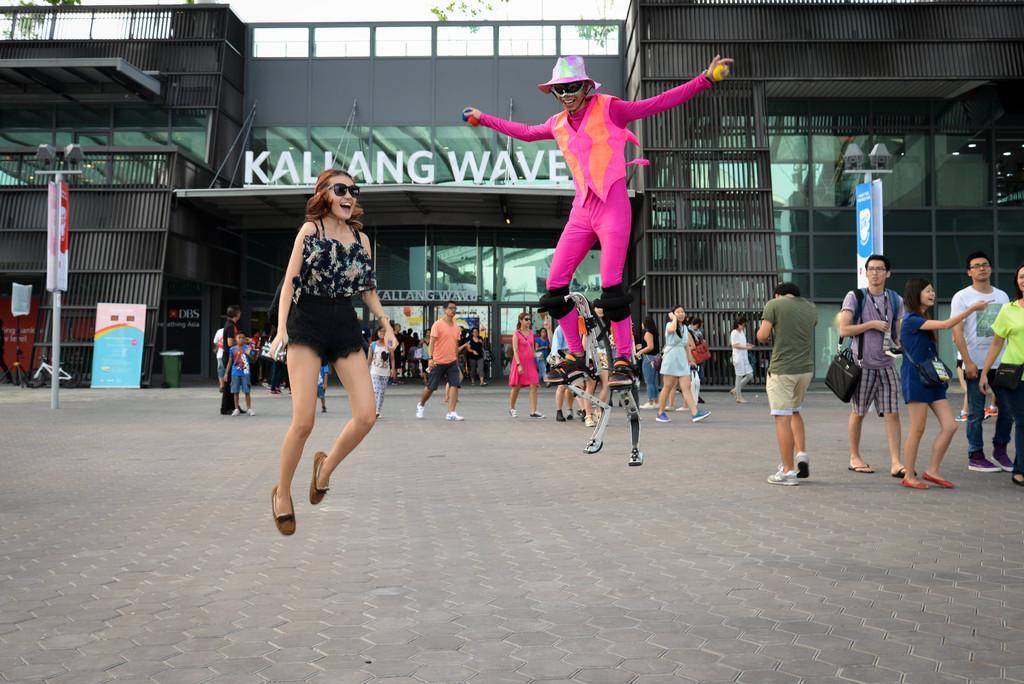Could you give a brief overview of what you see in this image? Here in this picture we can see two persons jumping on the road and we can see two persons standing and walking over there and behind them we can see a store, we can see light posts, banners and hoardings here and there and in the far we can see trees present over there. 